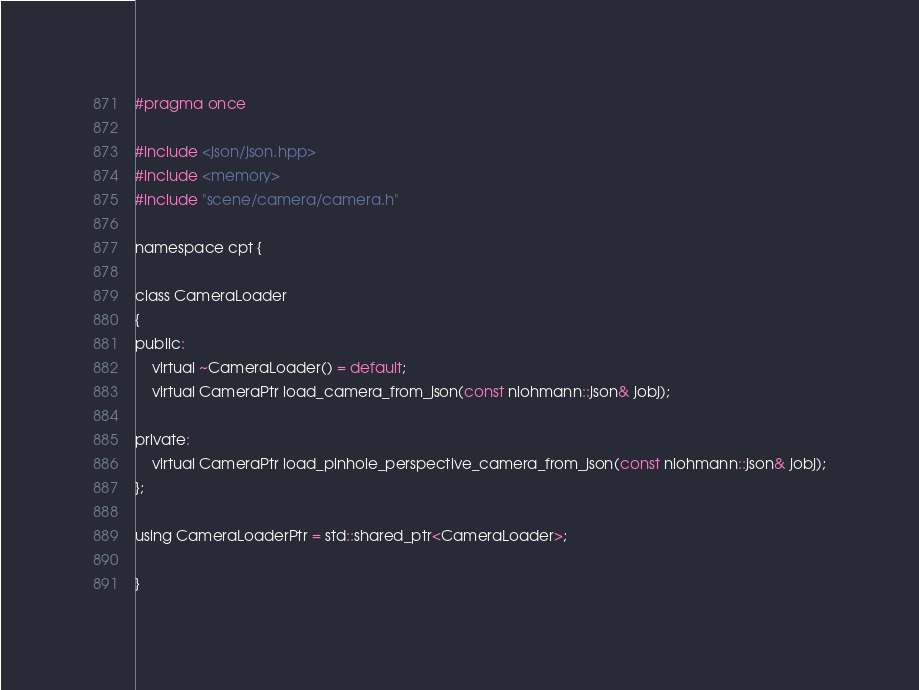<code> <loc_0><loc_0><loc_500><loc_500><_C_>#pragma once

#include <json/json.hpp>
#include <memory>
#include "scene/camera/camera.h"

namespace cpt {

class CameraLoader
{
public:
    virtual ~CameraLoader() = default;
    virtual CameraPtr load_camera_from_json(const nlohmann::json& jobj);

private:
    virtual CameraPtr load_pinhole_perspective_camera_from_json(const nlohmann::json& jobj);
};

using CameraLoaderPtr = std::shared_ptr<CameraLoader>;

}
</code> 